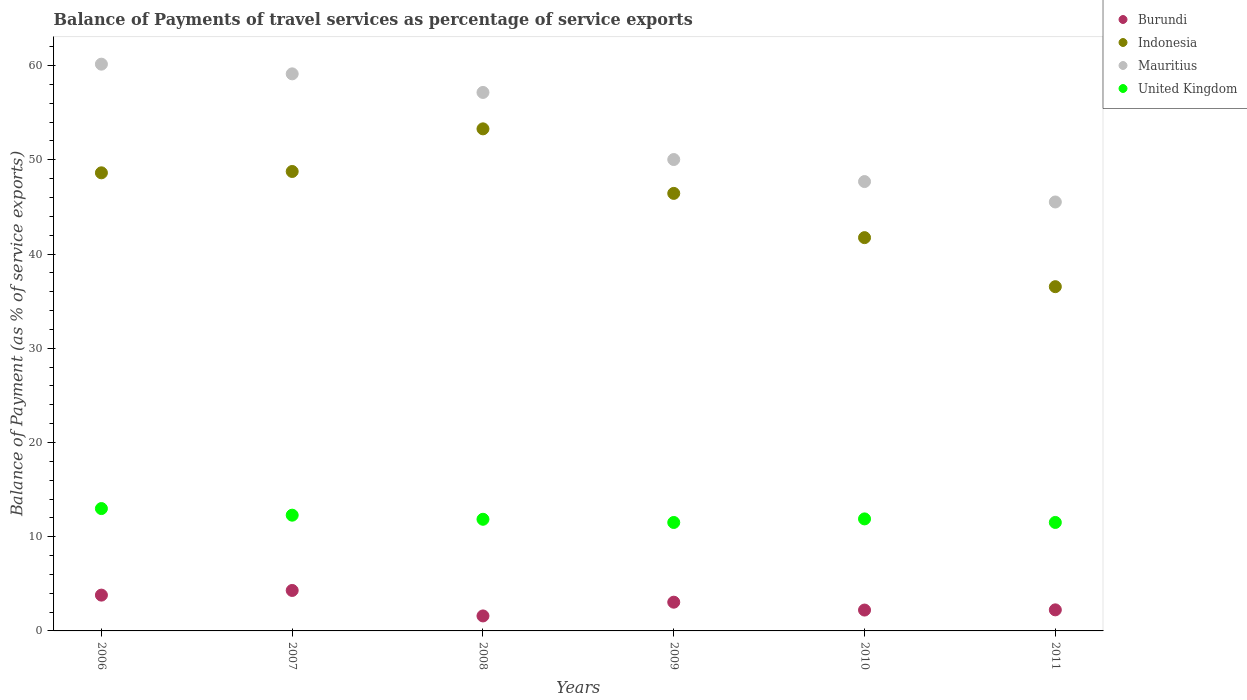How many different coloured dotlines are there?
Make the answer very short. 4. What is the balance of payments of travel services in Mauritius in 2006?
Your answer should be very brief. 60.15. Across all years, what is the maximum balance of payments of travel services in Indonesia?
Your answer should be compact. 53.28. Across all years, what is the minimum balance of payments of travel services in Burundi?
Offer a very short reply. 1.59. What is the total balance of payments of travel services in United Kingdom in the graph?
Your response must be concise. 72.03. What is the difference between the balance of payments of travel services in Mauritius in 2010 and that in 2011?
Your answer should be very brief. 2.17. What is the difference between the balance of payments of travel services in United Kingdom in 2006 and the balance of payments of travel services in Mauritius in 2010?
Keep it short and to the point. -34.7. What is the average balance of payments of travel services in Mauritius per year?
Offer a very short reply. 53.28. In the year 2010, what is the difference between the balance of payments of travel services in United Kingdom and balance of payments of travel services in Mauritius?
Provide a succinct answer. -35.8. What is the ratio of the balance of payments of travel services in Indonesia in 2010 to that in 2011?
Provide a succinct answer. 1.14. What is the difference between the highest and the second highest balance of payments of travel services in United Kingdom?
Your response must be concise. 0.7. What is the difference between the highest and the lowest balance of payments of travel services in Mauritius?
Provide a short and direct response. 14.63. Is the sum of the balance of payments of travel services in Indonesia in 2006 and 2009 greater than the maximum balance of payments of travel services in Burundi across all years?
Offer a very short reply. Yes. Is it the case that in every year, the sum of the balance of payments of travel services in Indonesia and balance of payments of travel services in United Kingdom  is greater than the balance of payments of travel services in Burundi?
Offer a very short reply. Yes. Does the balance of payments of travel services in Burundi monotonically increase over the years?
Keep it short and to the point. No. How many dotlines are there?
Keep it short and to the point. 4. What is the difference between two consecutive major ticks on the Y-axis?
Provide a succinct answer. 10. Are the values on the major ticks of Y-axis written in scientific E-notation?
Offer a very short reply. No. How are the legend labels stacked?
Make the answer very short. Vertical. What is the title of the graph?
Provide a succinct answer. Balance of Payments of travel services as percentage of service exports. Does "Togo" appear as one of the legend labels in the graph?
Offer a terse response. No. What is the label or title of the X-axis?
Your answer should be very brief. Years. What is the label or title of the Y-axis?
Offer a very short reply. Balance of Payment (as % of service exports). What is the Balance of Payment (as % of service exports) in Burundi in 2006?
Keep it short and to the point. 3.8. What is the Balance of Payment (as % of service exports) in Indonesia in 2006?
Your answer should be very brief. 48.62. What is the Balance of Payment (as % of service exports) of Mauritius in 2006?
Provide a succinct answer. 60.15. What is the Balance of Payment (as % of service exports) in United Kingdom in 2006?
Your response must be concise. 12.98. What is the Balance of Payment (as % of service exports) in Burundi in 2007?
Keep it short and to the point. 4.29. What is the Balance of Payment (as % of service exports) in Indonesia in 2007?
Your answer should be compact. 48.76. What is the Balance of Payment (as % of service exports) of Mauritius in 2007?
Your answer should be very brief. 59.12. What is the Balance of Payment (as % of service exports) in United Kingdom in 2007?
Give a very brief answer. 12.28. What is the Balance of Payment (as % of service exports) in Burundi in 2008?
Provide a short and direct response. 1.59. What is the Balance of Payment (as % of service exports) in Indonesia in 2008?
Give a very brief answer. 53.28. What is the Balance of Payment (as % of service exports) in Mauritius in 2008?
Provide a short and direct response. 57.15. What is the Balance of Payment (as % of service exports) in United Kingdom in 2008?
Your response must be concise. 11.85. What is the Balance of Payment (as % of service exports) in Burundi in 2009?
Your response must be concise. 3.05. What is the Balance of Payment (as % of service exports) of Indonesia in 2009?
Your response must be concise. 46.43. What is the Balance of Payment (as % of service exports) in Mauritius in 2009?
Your response must be concise. 50.03. What is the Balance of Payment (as % of service exports) of United Kingdom in 2009?
Give a very brief answer. 11.51. What is the Balance of Payment (as % of service exports) of Burundi in 2010?
Provide a succinct answer. 2.21. What is the Balance of Payment (as % of service exports) of Indonesia in 2010?
Ensure brevity in your answer.  41.74. What is the Balance of Payment (as % of service exports) of Mauritius in 2010?
Provide a short and direct response. 47.69. What is the Balance of Payment (as % of service exports) in United Kingdom in 2010?
Your response must be concise. 11.89. What is the Balance of Payment (as % of service exports) in Burundi in 2011?
Make the answer very short. 2.24. What is the Balance of Payment (as % of service exports) of Indonesia in 2011?
Offer a very short reply. 36.53. What is the Balance of Payment (as % of service exports) in Mauritius in 2011?
Keep it short and to the point. 45.52. What is the Balance of Payment (as % of service exports) in United Kingdom in 2011?
Offer a terse response. 11.51. Across all years, what is the maximum Balance of Payment (as % of service exports) in Burundi?
Keep it short and to the point. 4.29. Across all years, what is the maximum Balance of Payment (as % of service exports) in Indonesia?
Make the answer very short. 53.28. Across all years, what is the maximum Balance of Payment (as % of service exports) in Mauritius?
Your response must be concise. 60.15. Across all years, what is the maximum Balance of Payment (as % of service exports) in United Kingdom?
Ensure brevity in your answer.  12.98. Across all years, what is the minimum Balance of Payment (as % of service exports) in Burundi?
Keep it short and to the point. 1.59. Across all years, what is the minimum Balance of Payment (as % of service exports) in Indonesia?
Give a very brief answer. 36.53. Across all years, what is the minimum Balance of Payment (as % of service exports) of Mauritius?
Give a very brief answer. 45.52. Across all years, what is the minimum Balance of Payment (as % of service exports) in United Kingdom?
Ensure brevity in your answer.  11.51. What is the total Balance of Payment (as % of service exports) in Burundi in the graph?
Provide a succinct answer. 17.18. What is the total Balance of Payment (as % of service exports) in Indonesia in the graph?
Ensure brevity in your answer.  275.37. What is the total Balance of Payment (as % of service exports) in Mauritius in the graph?
Ensure brevity in your answer.  319.66. What is the total Balance of Payment (as % of service exports) of United Kingdom in the graph?
Keep it short and to the point. 72.03. What is the difference between the Balance of Payment (as % of service exports) of Burundi in 2006 and that in 2007?
Offer a terse response. -0.49. What is the difference between the Balance of Payment (as % of service exports) in Indonesia in 2006 and that in 2007?
Ensure brevity in your answer.  -0.14. What is the difference between the Balance of Payment (as % of service exports) of Mauritius in 2006 and that in 2007?
Offer a terse response. 1.03. What is the difference between the Balance of Payment (as % of service exports) in United Kingdom in 2006 and that in 2007?
Your answer should be very brief. 0.7. What is the difference between the Balance of Payment (as % of service exports) in Burundi in 2006 and that in 2008?
Offer a terse response. 2.21. What is the difference between the Balance of Payment (as % of service exports) of Indonesia in 2006 and that in 2008?
Your response must be concise. -4.67. What is the difference between the Balance of Payment (as % of service exports) in Mauritius in 2006 and that in 2008?
Ensure brevity in your answer.  3. What is the difference between the Balance of Payment (as % of service exports) in United Kingdom in 2006 and that in 2008?
Keep it short and to the point. 1.14. What is the difference between the Balance of Payment (as % of service exports) in Burundi in 2006 and that in 2009?
Offer a very short reply. 0.75. What is the difference between the Balance of Payment (as % of service exports) of Indonesia in 2006 and that in 2009?
Offer a very short reply. 2.18. What is the difference between the Balance of Payment (as % of service exports) of Mauritius in 2006 and that in 2009?
Make the answer very short. 10.12. What is the difference between the Balance of Payment (as % of service exports) of United Kingdom in 2006 and that in 2009?
Offer a very short reply. 1.48. What is the difference between the Balance of Payment (as % of service exports) of Burundi in 2006 and that in 2010?
Your response must be concise. 1.59. What is the difference between the Balance of Payment (as % of service exports) of Indonesia in 2006 and that in 2010?
Your response must be concise. 6.88. What is the difference between the Balance of Payment (as % of service exports) in Mauritius in 2006 and that in 2010?
Your response must be concise. 12.46. What is the difference between the Balance of Payment (as % of service exports) in United Kingdom in 2006 and that in 2010?
Your response must be concise. 1.1. What is the difference between the Balance of Payment (as % of service exports) in Burundi in 2006 and that in 2011?
Offer a terse response. 1.56. What is the difference between the Balance of Payment (as % of service exports) of Indonesia in 2006 and that in 2011?
Ensure brevity in your answer.  12.08. What is the difference between the Balance of Payment (as % of service exports) of Mauritius in 2006 and that in 2011?
Provide a succinct answer. 14.63. What is the difference between the Balance of Payment (as % of service exports) in United Kingdom in 2006 and that in 2011?
Give a very brief answer. 1.47. What is the difference between the Balance of Payment (as % of service exports) of Burundi in 2007 and that in 2008?
Your answer should be compact. 2.7. What is the difference between the Balance of Payment (as % of service exports) in Indonesia in 2007 and that in 2008?
Offer a very short reply. -4.52. What is the difference between the Balance of Payment (as % of service exports) of Mauritius in 2007 and that in 2008?
Your answer should be very brief. 1.97. What is the difference between the Balance of Payment (as % of service exports) of United Kingdom in 2007 and that in 2008?
Provide a succinct answer. 0.43. What is the difference between the Balance of Payment (as % of service exports) in Burundi in 2007 and that in 2009?
Offer a very short reply. 1.25. What is the difference between the Balance of Payment (as % of service exports) in Indonesia in 2007 and that in 2009?
Your answer should be compact. 2.32. What is the difference between the Balance of Payment (as % of service exports) in Mauritius in 2007 and that in 2009?
Offer a very short reply. 9.09. What is the difference between the Balance of Payment (as % of service exports) of United Kingdom in 2007 and that in 2009?
Provide a short and direct response. 0.77. What is the difference between the Balance of Payment (as % of service exports) of Burundi in 2007 and that in 2010?
Make the answer very short. 2.08. What is the difference between the Balance of Payment (as % of service exports) in Indonesia in 2007 and that in 2010?
Your answer should be compact. 7.02. What is the difference between the Balance of Payment (as % of service exports) of Mauritius in 2007 and that in 2010?
Ensure brevity in your answer.  11.43. What is the difference between the Balance of Payment (as % of service exports) of United Kingdom in 2007 and that in 2010?
Your answer should be compact. 0.39. What is the difference between the Balance of Payment (as % of service exports) of Burundi in 2007 and that in 2011?
Give a very brief answer. 2.06. What is the difference between the Balance of Payment (as % of service exports) of Indonesia in 2007 and that in 2011?
Your answer should be very brief. 12.22. What is the difference between the Balance of Payment (as % of service exports) in Mauritius in 2007 and that in 2011?
Provide a succinct answer. 13.6. What is the difference between the Balance of Payment (as % of service exports) of United Kingdom in 2007 and that in 2011?
Give a very brief answer. 0.77. What is the difference between the Balance of Payment (as % of service exports) in Burundi in 2008 and that in 2009?
Offer a very short reply. -1.46. What is the difference between the Balance of Payment (as % of service exports) of Indonesia in 2008 and that in 2009?
Provide a succinct answer. 6.85. What is the difference between the Balance of Payment (as % of service exports) of Mauritius in 2008 and that in 2009?
Your answer should be compact. 7.12. What is the difference between the Balance of Payment (as % of service exports) of United Kingdom in 2008 and that in 2009?
Give a very brief answer. 0.34. What is the difference between the Balance of Payment (as % of service exports) in Burundi in 2008 and that in 2010?
Make the answer very short. -0.62. What is the difference between the Balance of Payment (as % of service exports) in Indonesia in 2008 and that in 2010?
Your response must be concise. 11.55. What is the difference between the Balance of Payment (as % of service exports) in Mauritius in 2008 and that in 2010?
Offer a terse response. 9.46. What is the difference between the Balance of Payment (as % of service exports) of United Kingdom in 2008 and that in 2010?
Keep it short and to the point. -0.04. What is the difference between the Balance of Payment (as % of service exports) in Burundi in 2008 and that in 2011?
Make the answer very short. -0.64. What is the difference between the Balance of Payment (as % of service exports) of Indonesia in 2008 and that in 2011?
Ensure brevity in your answer.  16.75. What is the difference between the Balance of Payment (as % of service exports) in Mauritius in 2008 and that in 2011?
Your response must be concise. 11.62. What is the difference between the Balance of Payment (as % of service exports) in United Kingdom in 2008 and that in 2011?
Offer a terse response. 0.34. What is the difference between the Balance of Payment (as % of service exports) in Burundi in 2009 and that in 2010?
Provide a short and direct response. 0.83. What is the difference between the Balance of Payment (as % of service exports) of Indonesia in 2009 and that in 2010?
Make the answer very short. 4.7. What is the difference between the Balance of Payment (as % of service exports) in Mauritius in 2009 and that in 2010?
Offer a terse response. 2.34. What is the difference between the Balance of Payment (as % of service exports) of United Kingdom in 2009 and that in 2010?
Your answer should be compact. -0.38. What is the difference between the Balance of Payment (as % of service exports) in Burundi in 2009 and that in 2011?
Offer a very short reply. 0.81. What is the difference between the Balance of Payment (as % of service exports) in Indonesia in 2009 and that in 2011?
Your answer should be very brief. 9.9. What is the difference between the Balance of Payment (as % of service exports) of Mauritius in 2009 and that in 2011?
Ensure brevity in your answer.  4.5. What is the difference between the Balance of Payment (as % of service exports) of United Kingdom in 2009 and that in 2011?
Give a very brief answer. -0. What is the difference between the Balance of Payment (as % of service exports) of Burundi in 2010 and that in 2011?
Your answer should be compact. -0.02. What is the difference between the Balance of Payment (as % of service exports) in Indonesia in 2010 and that in 2011?
Provide a succinct answer. 5.2. What is the difference between the Balance of Payment (as % of service exports) of Mauritius in 2010 and that in 2011?
Make the answer very short. 2.17. What is the difference between the Balance of Payment (as % of service exports) in United Kingdom in 2010 and that in 2011?
Provide a succinct answer. 0.38. What is the difference between the Balance of Payment (as % of service exports) of Burundi in 2006 and the Balance of Payment (as % of service exports) of Indonesia in 2007?
Your answer should be compact. -44.96. What is the difference between the Balance of Payment (as % of service exports) in Burundi in 2006 and the Balance of Payment (as % of service exports) in Mauritius in 2007?
Give a very brief answer. -55.32. What is the difference between the Balance of Payment (as % of service exports) of Burundi in 2006 and the Balance of Payment (as % of service exports) of United Kingdom in 2007?
Provide a succinct answer. -8.48. What is the difference between the Balance of Payment (as % of service exports) in Indonesia in 2006 and the Balance of Payment (as % of service exports) in Mauritius in 2007?
Ensure brevity in your answer.  -10.5. What is the difference between the Balance of Payment (as % of service exports) of Indonesia in 2006 and the Balance of Payment (as % of service exports) of United Kingdom in 2007?
Your answer should be very brief. 36.33. What is the difference between the Balance of Payment (as % of service exports) of Mauritius in 2006 and the Balance of Payment (as % of service exports) of United Kingdom in 2007?
Your answer should be compact. 47.87. What is the difference between the Balance of Payment (as % of service exports) of Burundi in 2006 and the Balance of Payment (as % of service exports) of Indonesia in 2008?
Offer a terse response. -49.48. What is the difference between the Balance of Payment (as % of service exports) in Burundi in 2006 and the Balance of Payment (as % of service exports) in Mauritius in 2008?
Offer a very short reply. -53.35. What is the difference between the Balance of Payment (as % of service exports) in Burundi in 2006 and the Balance of Payment (as % of service exports) in United Kingdom in 2008?
Ensure brevity in your answer.  -8.05. What is the difference between the Balance of Payment (as % of service exports) of Indonesia in 2006 and the Balance of Payment (as % of service exports) of Mauritius in 2008?
Your response must be concise. -8.53. What is the difference between the Balance of Payment (as % of service exports) of Indonesia in 2006 and the Balance of Payment (as % of service exports) of United Kingdom in 2008?
Your answer should be very brief. 36.77. What is the difference between the Balance of Payment (as % of service exports) of Mauritius in 2006 and the Balance of Payment (as % of service exports) of United Kingdom in 2008?
Your answer should be compact. 48.3. What is the difference between the Balance of Payment (as % of service exports) in Burundi in 2006 and the Balance of Payment (as % of service exports) in Indonesia in 2009?
Your answer should be very brief. -42.63. What is the difference between the Balance of Payment (as % of service exports) in Burundi in 2006 and the Balance of Payment (as % of service exports) in Mauritius in 2009?
Your response must be concise. -46.23. What is the difference between the Balance of Payment (as % of service exports) in Burundi in 2006 and the Balance of Payment (as % of service exports) in United Kingdom in 2009?
Ensure brevity in your answer.  -7.71. What is the difference between the Balance of Payment (as % of service exports) of Indonesia in 2006 and the Balance of Payment (as % of service exports) of Mauritius in 2009?
Your answer should be very brief. -1.41. What is the difference between the Balance of Payment (as % of service exports) of Indonesia in 2006 and the Balance of Payment (as % of service exports) of United Kingdom in 2009?
Keep it short and to the point. 37.11. What is the difference between the Balance of Payment (as % of service exports) in Mauritius in 2006 and the Balance of Payment (as % of service exports) in United Kingdom in 2009?
Your answer should be very brief. 48.64. What is the difference between the Balance of Payment (as % of service exports) in Burundi in 2006 and the Balance of Payment (as % of service exports) in Indonesia in 2010?
Make the answer very short. -37.94. What is the difference between the Balance of Payment (as % of service exports) in Burundi in 2006 and the Balance of Payment (as % of service exports) in Mauritius in 2010?
Your answer should be compact. -43.89. What is the difference between the Balance of Payment (as % of service exports) of Burundi in 2006 and the Balance of Payment (as % of service exports) of United Kingdom in 2010?
Your answer should be very brief. -8.09. What is the difference between the Balance of Payment (as % of service exports) in Indonesia in 2006 and the Balance of Payment (as % of service exports) in Mauritius in 2010?
Give a very brief answer. 0.93. What is the difference between the Balance of Payment (as % of service exports) of Indonesia in 2006 and the Balance of Payment (as % of service exports) of United Kingdom in 2010?
Keep it short and to the point. 36.73. What is the difference between the Balance of Payment (as % of service exports) in Mauritius in 2006 and the Balance of Payment (as % of service exports) in United Kingdom in 2010?
Your answer should be very brief. 48.26. What is the difference between the Balance of Payment (as % of service exports) of Burundi in 2006 and the Balance of Payment (as % of service exports) of Indonesia in 2011?
Offer a very short reply. -32.73. What is the difference between the Balance of Payment (as % of service exports) of Burundi in 2006 and the Balance of Payment (as % of service exports) of Mauritius in 2011?
Keep it short and to the point. -41.72. What is the difference between the Balance of Payment (as % of service exports) in Burundi in 2006 and the Balance of Payment (as % of service exports) in United Kingdom in 2011?
Provide a short and direct response. -7.71. What is the difference between the Balance of Payment (as % of service exports) in Indonesia in 2006 and the Balance of Payment (as % of service exports) in Mauritius in 2011?
Offer a very short reply. 3.09. What is the difference between the Balance of Payment (as % of service exports) of Indonesia in 2006 and the Balance of Payment (as % of service exports) of United Kingdom in 2011?
Provide a short and direct response. 37.11. What is the difference between the Balance of Payment (as % of service exports) of Mauritius in 2006 and the Balance of Payment (as % of service exports) of United Kingdom in 2011?
Provide a short and direct response. 48.64. What is the difference between the Balance of Payment (as % of service exports) in Burundi in 2007 and the Balance of Payment (as % of service exports) in Indonesia in 2008?
Ensure brevity in your answer.  -48.99. What is the difference between the Balance of Payment (as % of service exports) in Burundi in 2007 and the Balance of Payment (as % of service exports) in Mauritius in 2008?
Keep it short and to the point. -52.85. What is the difference between the Balance of Payment (as % of service exports) of Burundi in 2007 and the Balance of Payment (as % of service exports) of United Kingdom in 2008?
Offer a terse response. -7.55. What is the difference between the Balance of Payment (as % of service exports) in Indonesia in 2007 and the Balance of Payment (as % of service exports) in Mauritius in 2008?
Provide a succinct answer. -8.39. What is the difference between the Balance of Payment (as % of service exports) in Indonesia in 2007 and the Balance of Payment (as % of service exports) in United Kingdom in 2008?
Ensure brevity in your answer.  36.91. What is the difference between the Balance of Payment (as % of service exports) of Mauritius in 2007 and the Balance of Payment (as % of service exports) of United Kingdom in 2008?
Your answer should be compact. 47.27. What is the difference between the Balance of Payment (as % of service exports) in Burundi in 2007 and the Balance of Payment (as % of service exports) in Indonesia in 2009?
Make the answer very short. -42.14. What is the difference between the Balance of Payment (as % of service exports) in Burundi in 2007 and the Balance of Payment (as % of service exports) in Mauritius in 2009?
Offer a very short reply. -45.73. What is the difference between the Balance of Payment (as % of service exports) of Burundi in 2007 and the Balance of Payment (as % of service exports) of United Kingdom in 2009?
Offer a very short reply. -7.21. What is the difference between the Balance of Payment (as % of service exports) in Indonesia in 2007 and the Balance of Payment (as % of service exports) in Mauritius in 2009?
Your answer should be compact. -1.27. What is the difference between the Balance of Payment (as % of service exports) in Indonesia in 2007 and the Balance of Payment (as % of service exports) in United Kingdom in 2009?
Keep it short and to the point. 37.25. What is the difference between the Balance of Payment (as % of service exports) in Mauritius in 2007 and the Balance of Payment (as % of service exports) in United Kingdom in 2009?
Keep it short and to the point. 47.61. What is the difference between the Balance of Payment (as % of service exports) of Burundi in 2007 and the Balance of Payment (as % of service exports) of Indonesia in 2010?
Provide a short and direct response. -37.44. What is the difference between the Balance of Payment (as % of service exports) in Burundi in 2007 and the Balance of Payment (as % of service exports) in Mauritius in 2010?
Offer a terse response. -43.39. What is the difference between the Balance of Payment (as % of service exports) in Burundi in 2007 and the Balance of Payment (as % of service exports) in United Kingdom in 2010?
Offer a very short reply. -7.59. What is the difference between the Balance of Payment (as % of service exports) of Indonesia in 2007 and the Balance of Payment (as % of service exports) of Mauritius in 2010?
Provide a succinct answer. 1.07. What is the difference between the Balance of Payment (as % of service exports) of Indonesia in 2007 and the Balance of Payment (as % of service exports) of United Kingdom in 2010?
Make the answer very short. 36.87. What is the difference between the Balance of Payment (as % of service exports) of Mauritius in 2007 and the Balance of Payment (as % of service exports) of United Kingdom in 2010?
Your answer should be very brief. 47.23. What is the difference between the Balance of Payment (as % of service exports) in Burundi in 2007 and the Balance of Payment (as % of service exports) in Indonesia in 2011?
Keep it short and to the point. -32.24. What is the difference between the Balance of Payment (as % of service exports) in Burundi in 2007 and the Balance of Payment (as % of service exports) in Mauritius in 2011?
Make the answer very short. -41.23. What is the difference between the Balance of Payment (as % of service exports) in Burundi in 2007 and the Balance of Payment (as % of service exports) in United Kingdom in 2011?
Keep it short and to the point. -7.22. What is the difference between the Balance of Payment (as % of service exports) in Indonesia in 2007 and the Balance of Payment (as % of service exports) in Mauritius in 2011?
Offer a very short reply. 3.24. What is the difference between the Balance of Payment (as % of service exports) of Indonesia in 2007 and the Balance of Payment (as % of service exports) of United Kingdom in 2011?
Offer a terse response. 37.25. What is the difference between the Balance of Payment (as % of service exports) of Mauritius in 2007 and the Balance of Payment (as % of service exports) of United Kingdom in 2011?
Provide a succinct answer. 47.61. What is the difference between the Balance of Payment (as % of service exports) of Burundi in 2008 and the Balance of Payment (as % of service exports) of Indonesia in 2009?
Offer a very short reply. -44.84. What is the difference between the Balance of Payment (as % of service exports) in Burundi in 2008 and the Balance of Payment (as % of service exports) in Mauritius in 2009?
Keep it short and to the point. -48.44. What is the difference between the Balance of Payment (as % of service exports) of Burundi in 2008 and the Balance of Payment (as % of service exports) of United Kingdom in 2009?
Make the answer very short. -9.92. What is the difference between the Balance of Payment (as % of service exports) in Indonesia in 2008 and the Balance of Payment (as % of service exports) in Mauritius in 2009?
Make the answer very short. 3.26. What is the difference between the Balance of Payment (as % of service exports) in Indonesia in 2008 and the Balance of Payment (as % of service exports) in United Kingdom in 2009?
Provide a short and direct response. 41.77. What is the difference between the Balance of Payment (as % of service exports) in Mauritius in 2008 and the Balance of Payment (as % of service exports) in United Kingdom in 2009?
Your answer should be compact. 45.64. What is the difference between the Balance of Payment (as % of service exports) of Burundi in 2008 and the Balance of Payment (as % of service exports) of Indonesia in 2010?
Your answer should be very brief. -40.15. What is the difference between the Balance of Payment (as % of service exports) of Burundi in 2008 and the Balance of Payment (as % of service exports) of Mauritius in 2010?
Ensure brevity in your answer.  -46.1. What is the difference between the Balance of Payment (as % of service exports) of Burundi in 2008 and the Balance of Payment (as % of service exports) of United Kingdom in 2010?
Keep it short and to the point. -10.3. What is the difference between the Balance of Payment (as % of service exports) of Indonesia in 2008 and the Balance of Payment (as % of service exports) of Mauritius in 2010?
Your answer should be very brief. 5.59. What is the difference between the Balance of Payment (as % of service exports) of Indonesia in 2008 and the Balance of Payment (as % of service exports) of United Kingdom in 2010?
Your answer should be very brief. 41.39. What is the difference between the Balance of Payment (as % of service exports) in Mauritius in 2008 and the Balance of Payment (as % of service exports) in United Kingdom in 2010?
Your answer should be very brief. 45.26. What is the difference between the Balance of Payment (as % of service exports) in Burundi in 2008 and the Balance of Payment (as % of service exports) in Indonesia in 2011?
Keep it short and to the point. -34.94. What is the difference between the Balance of Payment (as % of service exports) of Burundi in 2008 and the Balance of Payment (as % of service exports) of Mauritius in 2011?
Ensure brevity in your answer.  -43.93. What is the difference between the Balance of Payment (as % of service exports) in Burundi in 2008 and the Balance of Payment (as % of service exports) in United Kingdom in 2011?
Keep it short and to the point. -9.92. What is the difference between the Balance of Payment (as % of service exports) in Indonesia in 2008 and the Balance of Payment (as % of service exports) in Mauritius in 2011?
Provide a short and direct response. 7.76. What is the difference between the Balance of Payment (as % of service exports) in Indonesia in 2008 and the Balance of Payment (as % of service exports) in United Kingdom in 2011?
Give a very brief answer. 41.77. What is the difference between the Balance of Payment (as % of service exports) of Mauritius in 2008 and the Balance of Payment (as % of service exports) of United Kingdom in 2011?
Your response must be concise. 45.64. What is the difference between the Balance of Payment (as % of service exports) of Burundi in 2009 and the Balance of Payment (as % of service exports) of Indonesia in 2010?
Provide a short and direct response. -38.69. What is the difference between the Balance of Payment (as % of service exports) in Burundi in 2009 and the Balance of Payment (as % of service exports) in Mauritius in 2010?
Ensure brevity in your answer.  -44.64. What is the difference between the Balance of Payment (as % of service exports) in Burundi in 2009 and the Balance of Payment (as % of service exports) in United Kingdom in 2010?
Make the answer very short. -8.84. What is the difference between the Balance of Payment (as % of service exports) of Indonesia in 2009 and the Balance of Payment (as % of service exports) of Mauritius in 2010?
Provide a succinct answer. -1.25. What is the difference between the Balance of Payment (as % of service exports) in Indonesia in 2009 and the Balance of Payment (as % of service exports) in United Kingdom in 2010?
Offer a very short reply. 34.55. What is the difference between the Balance of Payment (as % of service exports) in Mauritius in 2009 and the Balance of Payment (as % of service exports) in United Kingdom in 2010?
Your response must be concise. 38.14. What is the difference between the Balance of Payment (as % of service exports) of Burundi in 2009 and the Balance of Payment (as % of service exports) of Indonesia in 2011?
Make the answer very short. -33.48. What is the difference between the Balance of Payment (as % of service exports) in Burundi in 2009 and the Balance of Payment (as % of service exports) in Mauritius in 2011?
Provide a succinct answer. -42.47. What is the difference between the Balance of Payment (as % of service exports) of Burundi in 2009 and the Balance of Payment (as % of service exports) of United Kingdom in 2011?
Ensure brevity in your answer.  -8.46. What is the difference between the Balance of Payment (as % of service exports) of Indonesia in 2009 and the Balance of Payment (as % of service exports) of Mauritius in 2011?
Ensure brevity in your answer.  0.91. What is the difference between the Balance of Payment (as % of service exports) of Indonesia in 2009 and the Balance of Payment (as % of service exports) of United Kingdom in 2011?
Keep it short and to the point. 34.92. What is the difference between the Balance of Payment (as % of service exports) in Mauritius in 2009 and the Balance of Payment (as % of service exports) in United Kingdom in 2011?
Offer a terse response. 38.52. What is the difference between the Balance of Payment (as % of service exports) of Burundi in 2010 and the Balance of Payment (as % of service exports) of Indonesia in 2011?
Make the answer very short. -34.32. What is the difference between the Balance of Payment (as % of service exports) of Burundi in 2010 and the Balance of Payment (as % of service exports) of Mauritius in 2011?
Offer a terse response. -43.31. What is the difference between the Balance of Payment (as % of service exports) of Burundi in 2010 and the Balance of Payment (as % of service exports) of United Kingdom in 2011?
Provide a short and direct response. -9.3. What is the difference between the Balance of Payment (as % of service exports) of Indonesia in 2010 and the Balance of Payment (as % of service exports) of Mauritius in 2011?
Give a very brief answer. -3.78. What is the difference between the Balance of Payment (as % of service exports) in Indonesia in 2010 and the Balance of Payment (as % of service exports) in United Kingdom in 2011?
Offer a very short reply. 30.23. What is the difference between the Balance of Payment (as % of service exports) of Mauritius in 2010 and the Balance of Payment (as % of service exports) of United Kingdom in 2011?
Ensure brevity in your answer.  36.18. What is the average Balance of Payment (as % of service exports) in Burundi per year?
Give a very brief answer. 2.86. What is the average Balance of Payment (as % of service exports) in Indonesia per year?
Offer a very short reply. 45.89. What is the average Balance of Payment (as % of service exports) of Mauritius per year?
Offer a very short reply. 53.28. What is the average Balance of Payment (as % of service exports) in United Kingdom per year?
Give a very brief answer. 12. In the year 2006, what is the difference between the Balance of Payment (as % of service exports) in Burundi and Balance of Payment (as % of service exports) in Indonesia?
Your response must be concise. -44.82. In the year 2006, what is the difference between the Balance of Payment (as % of service exports) of Burundi and Balance of Payment (as % of service exports) of Mauritius?
Make the answer very short. -56.35. In the year 2006, what is the difference between the Balance of Payment (as % of service exports) of Burundi and Balance of Payment (as % of service exports) of United Kingdom?
Your answer should be very brief. -9.19. In the year 2006, what is the difference between the Balance of Payment (as % of service exports) of Indonesia and Balance of Payment (as % of service exports) of Mauritius?
Make the answer very short. -11.53. In the year 2006, what is the difference between the Balance of Payment (as % of service exports) of Indonesia and Balance of Payment (as % of service exports) of United Kingdom?
Make the answer very short. 35.63. In the year 2006, what is the difference between the Balance of Payment (as % of service exports) of Mauritius and Balance of Payment (as % of service exports) of United Kingdom?
Your answer should be compact. 47.16. In the year 2007, what is the difference between the Balance of Payment (as % of service exports) in Burundi and Balance of Payment (as % of service exports) in Indonesia?
Offer a terse response. -44.46. In the year 2007, what is the difference between the Balance of Payment (as % of service exports) in Burundi and Balance of Payment (as % of service exports) in Mauritius?
Make the answer very short. -54.83. In the year 2007, what is the difference between the Balance of Payment (as % of service exports) in Burundi and Balance of Payment (as % of service exports) in United Kingdom?
Keep it short and to the point. -7.99. In the year 2007, what is the difference between the Balance of Payment (as % of service exports) of Indonesia and Balance of Payment (as % of service exports) of Mauritius?
Provide a short and direct response. -10.36. In the year 2007, what is the difference between the Balance of Payment (as % of service exports) in Indonesia and Balance of Payment (as % of service exports) in United Kingdom?
Give a very brief answer. 36.48. In the year 2007, what is the difference between the Balance of Payment (as % of service exports) of Mauritius and Balance of Payment (as % of service exports) of United Kingdom?
Provide a succinct answer. 46.84. In the year 2008, what is the difference between the Balance of Payment (as % of service exports) in Burundi and Balance of Payment (as % of service exports) in Indonesia?
Your answer should be very brief. -51.69. In the year 2008, what is the difference between the Balance of Payment (as % of service exports) of Burundi and Balance of Payment (as % of service exports) of Mauritius?
Provide a succinct answer. -55.56. In the year 2008, what is the difference between the Balance of Payment (as % of service exports) of Burundi and Balance of Payment (as % of service exports) of United Kingdom?
Make the answer very short. -10.26. In the year 2008, what is the difference between the Balance of Payment (as % of service exports) of Indonesia and Balance of Payment (as % of service exports) of Mauritius?
Offer a terse response. -3.86. In the year 2008, what is the difference between the Balance of Payment (as % of service exports) in Indonesia and Balance of Payment (as % of service exports) in United Kingdom?
Provide a short and direct response. 41.44. In the year 2008, what is the difference between the Balance of Payment (as % of service exports) of Mauritius and Balance of Payment (as % of service exports) of United Kingdom?
Make the answer very short. 45.3. In the year 2009, what is the difference between the Balance of Payment (as % of service exports) in Burundi and Balance of Payment (as % of service exports) in Indonesia?
Your response must be concise. -43.38. In the year 2009, what is the difference between the Balance of Payment (as % of service exports) in Burundi and Balance of Payment (as % of service exports) in Mauritius?
Provide a short and direct response. -46.98. In the year 2009, what is the difference between the Balance of Payment (as % of service exports) in Burundi and Balance of Payment (as % of service exports) in United Kingdom?
Offer a very short reply. -8.46. In the year 2009, what is the difference between the Balance of Payment (as % of service exports) in Indonesia and Balance of Payment (as % of service exports) in Mauritius?
Keep it short and to the point. -3.59. In the year 2009, what is the difference between the Balance of Payment (as % of service exports) in Indonesia and Balance of Payment (as % of service exports) in United Kingdom?
Offer a terse response. 34.92. In the year 2009, what is the difference between the Balance of Payment (as % of service exports) of Mauritius and Balance of Payment (as % of service exports) of United Kingdom?
Your answer should be compact. 38.52. In the year 2010, what is the difference between the Balance of Payment (as % of service exports) in Burundi and Balance of Payment (as % of service exports) in Indonesia?
Your response must be concise. -39.52. In the year 2010, what is the difference between the Balance of Payment (as % of service exports) in Burundi and Balance of Payment (as % of service exports) in Mauritius?
Offer a terse response. -45.47. In the year 2010, what is the difference between the Balance of Payment (as % of service exports) of Burundi and Balance of Payment (as % of service exports) of United Kingdom?
Your answer should be compact. -9.67. In the year 2010, what is the difference between the Balance of Payment (as % of service exports) in Indonesia and Balance of Payment (as % of service exports) in Mauritius?
Keep it short and to the point. -5.95. In the year 2010, what is the difference between the Balance of Payment (as % of service exports) in Indonesia and Balance of Payment (as % of service exports) in United Kingdom?
Ensure brevity in your answer.  29.85. In the year 2010, what is the difference between the Balance of Payment (as % of service exports) in Mauritius and Balance of Payment (as % of service exports) in United Kingdom?
Your response must be concise. 35.8. In the year 2011, what is the difference between the Balance of Payment (as % of service exports) in Burundi and Balance of Payment (as % of service exports) in Indonesia?
Provide a succinct answer. -34.3. In the year 2011, what is the difference between the Balance of Payment (as % of service exports) of Burundi and Balance of Payment (as % of service exports) of Mauritius?
Your response must be concise. -43.29. In the year 2011, what is the difference between the Balance of Payment (as % of service exports) of Burundi and Balance of Payment (as % of service exports) of United Kingdom?
Your answer should be very brief. -9.28. In the year 2011, what is the difference between the Balance of Payment (as % of service exports) of Indonesia and Balance of Payment (as % of service exports) of Mauritius?
Your response must be concise. -8.99. In the year 2011, what is the difference between the Balance of Payment (as % of service exports) of Indonesia and Balance of Payment (as % of service exports) of United Kingdom?
Provide a short and direct response. 25.02. In the year 2011, what is the difference between the Balance of Payment (as % of service exports) in Mauritius and Balance of Payment (as % of service exports) in United Kingdom?
Provide a succinct answer. 34.01. What is the ratio of the Balance of Payment (as % of service exports) of Burundi in 2006 to that in 2007?
Keep it short and to the point. 0.88. What is the ratio of the Balance of Payment (as % of service exports) of Indonesia in 2006 to that in 2007?
Ensure brevity in your answer.  1. What is the ratio of the Balance of Payment (as % of service exports) in Mauritius in 2006 to that in 2007?
Offer a very short reply. 1.02. What is the ratio of the Balance of Payment (as % of service exports) in United Kingdom in 2006 to that in 2007?
Provide a succinct answer. 1.06. What is the ratio of the Balance of Payment (as % of service exports) in Burundi in 2006 to that in 2008?
Provide a short and direct response. 2.39. What is the ratio of the Balance of Payment (as % of service exports) of Indonesia in 2006 to that in 2008?
Offer a very short reply. 0.91. What is the ratio of the Balance of Payment (as % of service exports) of Mauritius in 2006 to that in 2008?
Your response must be concise. 1.05. What is the ratio of the Balance of Payment (as % of service exports) in United Kingdom in 2006 to that in 2008?
Your response must be concise. 1.1. What is the ratio of the Balance of Payment (as % of service exports) in Burundi in 2006 to that in 2009?
Your answer should be very brief. 1.25. What is the ratio of the Balance of Payment (as % of service exports) of Indonesia in 2006 to that in 2009?
Offer a very short reply. 1.05. What is the ratio of the Balance of Payment (as % of service exports) in Mauritius in 2006 to that in 2009?
Keep it short and to the point. 1.2. What is the ratio of the Balance of Payment (as % of service exports) of United Kingdom in 2006 to that in 2009?
Make the answer very short. 1.13. What is the ratio of the Balance of Payment (as % of service exports) in Burundi in 2006 to that in 2010?
Ensure brevity in your answer.  1.72. What is the ratio of the Balance of Payment (as % of service exports) in Indonesia in 2006 to that in 2010?
Keep it short and to the point. 1.16. What is the ratio of the Balance of Payment (as % of service exports) of Mauritius in 2006 to that in 2010?
Ensure brevity in your answer.  1.26. What is the ratio of the Balance of Payment (as % of service exports) in United Kingdom in 2006 to that in 2010?
Keep it short and to the point. 1.09. What is the ratio of the Balance of Payment (as % of service exports) in Burundi in 2006 to that in 2011?
Your answer should be compact. 1.7. What is the ratio of the Balance of Payment (as % of service exports) in Indonesia in 2006 to that in 2011?
Provide a short and direct response. 1.33. What is the ratio of the Balance of Payment (as % of service exports) in Mauritius in 2006 to that in 2011?
Provide a succinct answer. 1.32. What is the ratio of the Balance of Payment (as % of service exports) of United Kingdom in 2006 to that in 2011?
Provide a short and direct response. 1.13. What is the ratio of the Balance of Payment (as % of service exports) of Burundi in 2007 to that in 2008?
Offer a very short reply. 2.7. What is the ratio of the Balance of Payment (as % of service exports) in Indonesia in 2007 to that in 2008?
Give a very brief answer. 0.92. What is the ratio of the Balance of Payment (as % of service exports) in Mauritius in 2007 to that in 2008?
Offer a terse response. 1.03. What is the ratio of the Balance of Payment (as % of service exports) of United Kingdom in 2007 to that in 2008?
Give a very brief answer. 1.04. What is the ratio of the Balance of Payment (as % of service exports) of Burundi in 2007 to that in 2009?
Your answer should be very brief. 1.41. What is the ratio of the Balance of Payment (as % of service exports) in Indonesia in 2007 to that in 2009?
Give a very brief answer. 1.05. What is the ratio of the Balance of Payment (as % of service exports) of Mauritius in 2007 to that in 2009?
Give a very brief answer. 1.18. What is the ratio of the Balance of Payment (as % of service exports) of United Kingdom in 2007 to that in 2009?
Offer a very short reply. 1.07. What is the ratio of the Balance of Payment (as % of service exports) of Burundi in 2007 to that in 2010?
Provide a succinct answer. 1.94. What is the ratio of the Balance of Payment (as % of service exports) of Indonesia in 2007 to that in 2010?
Your answer should be compact. 1.17. What is the ratio of the Balance of Payment (as % of service exports) in Mauritius in 2007 to that in 2010?
Keep it short and to the point. 1.24. What is the ratio of the Balance of Payment (as % of service exports) of United Kingdom in 2007 to that in 2010?
Give a very brief answer. 1.03. What is the ratio of the Balance of Payment (as % of service exports) of Burundi in 2007 to that in 2011?
Your answer should be very brief. 1.92. What is the ratio of the Balance of Payment (as % of service exports) of Indonesia in 2007 to that in 2011?
Provide a short and direct response. 1.33. What is the ratio of the Balance of Payment (as % of service exports) of Mauritius in 2007 to that in 2011?
Provide a short and direct response. 1.3. What is the ratio of the Balance of Payment (as % of service exports) in United Kingdom in 2007 to that in 2011?
Your answer should be compact. 1.07. What is the ratio of the Balance of Payment (as % of service exports) in Burundi in 2008 to that in 2009?
Provide a short and direct response. 0.52. What is the ratio of the Balance of Payment (as % of service exports) in Indonesia in 2008 to that in 2009?
Offer a terse response. 1.15. What is the ratio of the Balance of Payment (as % of service exports) of Mauritius in 2008 to that in 2009?
Keep it short and to the point. 1.14. What is the ratio of the Balance of Payment (as % of service exports) in United Kingdom in 2008 to that in 2009?
Offer a terse response. 1.03. What is the ratio of the Balance of Payment (as % of service exports) in Burundi in 2008 to that in 2010?
Provide a succinct answer. 0.72. What is the ratio of the Balance of Payment (as % of service exports) in Indonesia in 2008 to that in 2010?
Ensure brevity in your answer.  1.28. What is the ratio of the Balance of Payment (as % of service exports) in Mauritius in 2008 to that in 2010?
Keep it short and to the point. 1.2. What is the ratio of the Balance of Payment (as % of service exports) in United Kingdom in 2008 to that in 2010?
Provide a succinct answer. 1. What is the ratio of the Balance of Payment (as % of service exports) in Burundi in 2008 to that in 2011?
Give a very brief answer. 0.71. What is the ratio of the Balance of Payment (as % of service exports) of Indonesia in 2008 to that in 2011?
Your answer should be very brief. 1.46. What is the ratio of the Balance of Payment (as % of service exports) in Mauritius in 2008 to that in 2011?
Provide a succinct answer. 1.26. What is the ratio of the Balance of Payment (as % of service exports) in United Kingdom in 2008 to that in 2011?
Give a very brief answer. 1.03. What is the ratio of the Balance of Payment (as % of service exports) of Burundi in 2009 to that in 2010?
Your response must be concise. 1.38. What is the ratio of the Balance of Payment (as % of service exports) in Indonesia in 2009 to that in 2010?
Provide a succinct answer. 1.11. What is the ratio of the Balance of Payment (as % of service exports) of Mauritius in 2009 to that in 2010?
Your response must be concise. 1.05. What is the ratio of the Balance of Payment (as % of service exports) in United Kingdom in 2009 to that in 2010?
Keep it short and to the point. 0.97. What is the ratio of the Balance of Payment (as % of service exports) of Burundi in 2009 to that in 2011?
Keep it short and to the point. 1.36. What is the ratio of the Balance of Payment (as % of service exports) of Indonesia in 2009 to that in 2011?
Offer a terse response. 1.27. What is the ratio of the Balance of Payment (as % of service exports) in Mauritius in 2009 to that in 2011?
Give a very brief answer. 1.1. What is the ratio of the Balance of Payment (as % of service exports) of United Kingdom in 2009 to that in 2011?
Your answer should be very brief. 1. What is the ratio of the Balance of Payment (as % of service exports) in Indonesia in 2010 to that in 2011?
Your answer should be very brief. 1.14. What is the ratio of the Balance of Payment (as % of service exports) in Mauritius in 2010 to that in 2011?
Offer a very short reply. 1.05. What is the ratio of the Balance of Payment (as % of service exports) in United Kingdom in 2010 to that in 2011?
Keep it short and to the point. 1.03. What is the difference between the highest and the second highest Balance of Payment (as % of service exports) in Burundi?
Keep it short and to the point. 0.49. What is the difference between the highest and the second highest Balance of Payment (as % of service exports) of Indonesia?
Your answer should be very brief. 4.52. What is the difference between the highest and the second highest Balance of Payment (as % of service exports) in Mauritius?
Provide a succinct answer. 1.03. What is the difference between the highest and the second highest Balance of Payment (as % of service exports) in United Kingdom?
Offer a very short reply. 0.7. What is the difference between the highest and the lowest Balance of Payment (as % of service exports) in Burundi?
Ensure brevity in your answer.  2.7. What is the difference between the highest and the lowest Balance of Payment (as % of service exports) in Indonesia?
Make the answer very short. 16.75. What is the difference between the highest and the lowest Balance of Payment (as % of service exports) of Mauritius?
Provide a succinct answer. 14.63. What is the difference between the highest and the lowest Balance of Payment (as % of service exports) in United Kingdom?
Offer a terse response. 1.48. 